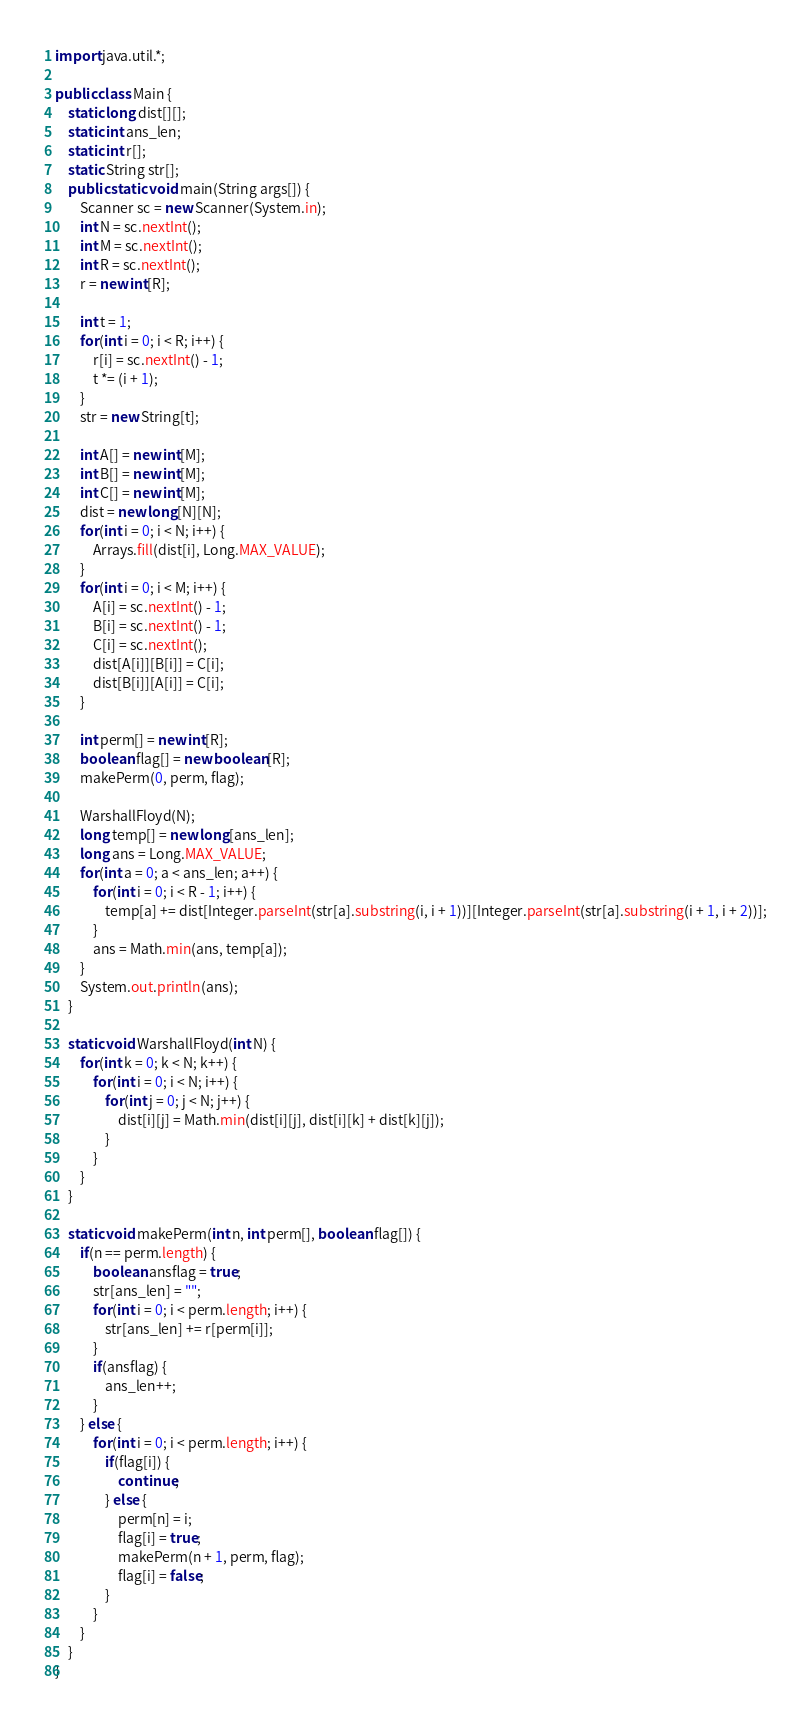<code> <loc_0><loc_0><loc_500><loc_500><_Java_>import java.util.*;

public class Main {
	static long dist[][];
	static int ans_len;
	static int r[];
	static String str[];
	public static void main(String args[]) {
		Scanner sc = new Scanner(System.in);
		int N = sc.nextInt();
		int M = sc.nextInt();
		int R = sc.nextInt();
		r = new int[R];
		
		int t = 1;
		for(int i = 0; i < R; i++) {
			r[i] = sc.nextInt() - 1;
			t *= (i + 1);
		}
		str = new String[t];
		
		int A[] = new int[M];
		int B[] = new int[M];
		int C[] = new int[M];
		dist = new long[N][N];
		for(int i = 0; i < N; i++) {
			Arrays.fill(dist[i], Long.MAX_VALUE);
		}
		for(int i = 0; i < M; i++) {
			A[i] = sc.nextInt() - 1;
			B[i] = sc.nextInt() - 1;
			C[i] = sc.nextInt();
			dist[A[i]][B[i]] = C[i];
			dist[B[i]][A[i]] = C[i];
		}
		
		int perm[] = new int[R];
		boolean flag[] = new boolean[R];
		makePerm(0, perm, flag);
		
		WarshallFloyd(N);
		long temp[] = new long[ans_len];
		long ans = Long.MAX_VALUE;
		for(int a = 0; a < ans_len; a++) {
			for(int i = 0; i < R - 1; i++) {
				temp[a] += dist[Integer.parseInt(str[a].substring(i, i + 1))][Integer.parseInt(str[a].substring(i + 1, i + 2))];
			}
			ans = Math.min(ans, temp[a]);
		}
		System.out.println(ans);
	}
	
	static void WarshallFloyd(int N) {
		for(int k = 0; k < N; k++) {
			for(int i = 0; i < N; i++) {
				for(int j = 0; j < N; j++) {
					dist[i][j] = Math.min(dist[i][j], dist[i][k] + dist[k][j]);
				}
			}
		}
	}
	
	static void makePerm(int n, int perm[], boolean flag[]) {
		if(n == perm.length) {
			boolean ansflag = true;
			str[ans_len] = "";
			for(int i = 0; i < perm.length; i++) {
				str[ans_len] += r[perm[i]];
			}
			if(ansflag) {
				ans_len++;
			}
		} else {
			for(int i = 0; i < perm.length; i++) {
				if(flag[i]) {
					continue;
				} else {
					perm[n] = i;
					flag[i] = true;
					makePerm(n + 1, perm, flag);
					flag[i] = false;
				}
			}
		}
	}
}
</code> 